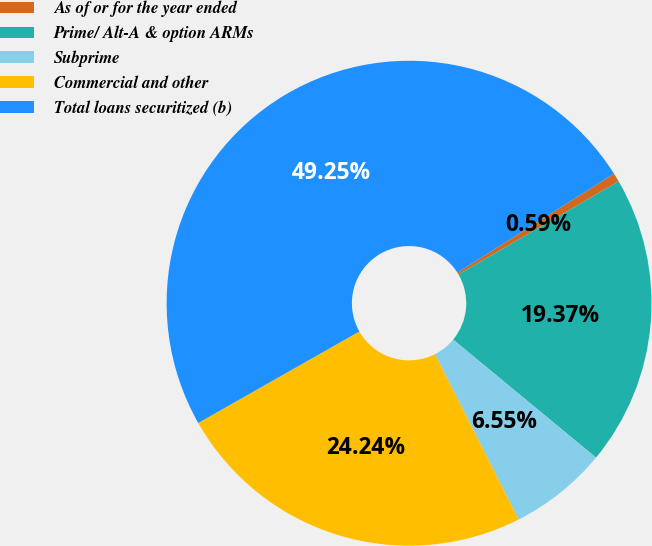Convert chart. <chart><loc_0><loc_0><loc_500><loc_500><pie_chart><fcel>As of or for the year ended<fcel>Prime/ Alt-A & option ARMs<fcel>Subprime<fcel>Commercial and other<fcel>Total loans securitized (b)<nl><fcel>0.59%<fcel>19.37%<fcel>6.55%<fcel>24.24%<fcel>49.25%<nl></chart> 